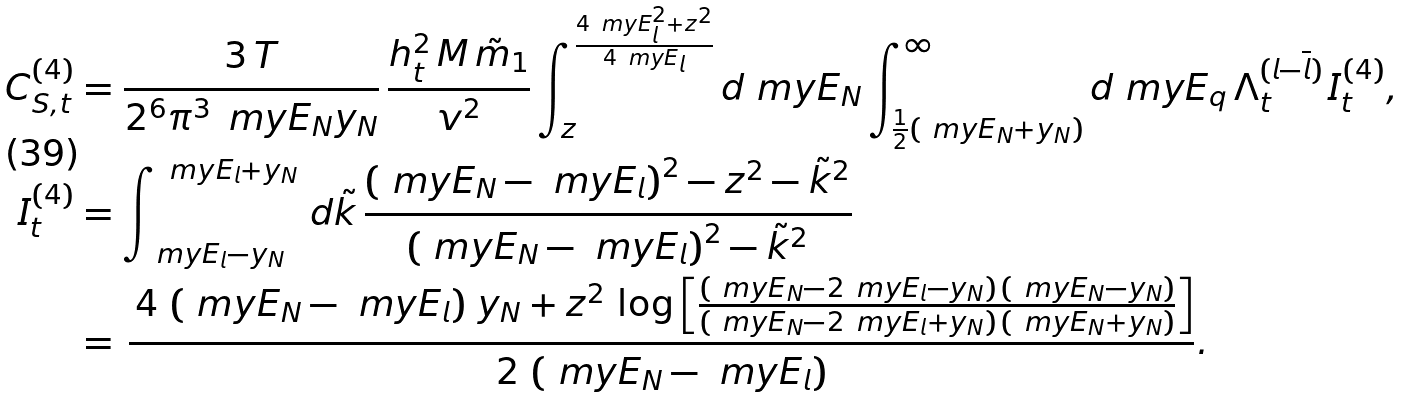Convert formula to latex. <formula><loc_0><loc_0><loc_500><loc_500>C _ { S , t } ^ { ( 4 ) } & = \frac { 3 \, T } { 2 ^ { 6 } \pi ^ { 3 } \, \ m y E _ { N } y _ { N } } \, \frac { h _ { t } ^ { 2 } \, M \, \tilde { m } _ { 1 } } { v ^ { 2 } } \int _ { z } ^ { \frac { 4 \ m y E _ { l } ^ { 2 } + z ^ { 2 } } { 4 \ m y E _ { l } } } d \ m y E _ { N } \int _ { \frac { 1 } { 2 } ( \ m y E _ { N } + y _ { N } ) } ^ { \infty } d \ m y E _ { q } \, \Lambda _ { t } ^ { ( l - \overline { l } ) } \, I _ { t } ^ { ( 4 ) } , \\ I _ { t } ^ { ( 4 ) } & = \int _ { \ m y E _ { l } - y _ { N } } ^ { \ m y E _ { l } + y _ { N } } \, d \tilde { k } \, \frac { \left ( \ m y E _ { N } - \ m y E _ { l } \right ) ^ { 2 } - z ^ { 2 } - \tilde { k } ^ { 2 } } { \left ( \ m y E _ { N } - \ m y E _ { l } \right ) ^ { 2 } - \tilde { k } ^ { 2 } } \\ & = \, \frac { \, 4 \, \left ( \ m y E _ { N } - \ m y E _ { l } \right ) \, y _ { N } + z ^ { 2 } \, \log \left [ \frac { \left ( \ m y E _ { N } - 2 \ m y E _ { l } - y _ { N } \right ) \, \left ( \ m y E _ { N } - y _ { N } \right ) } { \left ( \ m y E _ { N } - 2 \ m y E _ { l } + y _ { N } \right ) \, \left ( \ m y E _ { N } + y _ { N } \right ) } \right ] } { 2 \, \left ( \ m y E _ { N } - \ m y E _ { l } \right ) } .</formula> 